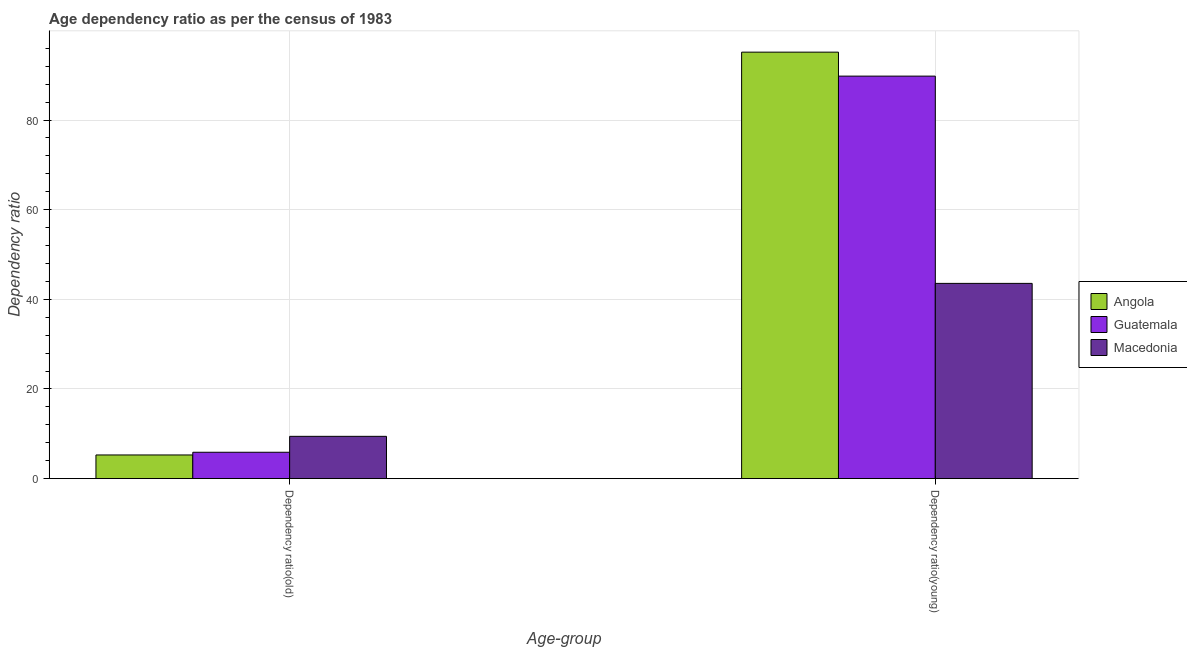Are the number of bars on each tick of the X-axis equal?
Offer a terse response. Yes. What is the label of the 1st group of bars from the left?
Your response must be concise. Dependency ratio(old). What is the age dependency ratio(old) in Guatemala?
Provide a succinct answer. 5.88. Across all countries, what is the maximum age dependency ratio(old)?
Your answer should be compact. 9.43. Across all countries, what is the minimum age dependency ratio(old)?
Your answer should be compact. 5.28. In which country was the age dependency ratio(old) maximum?
Make the answer very short. Macedonia. In which country was the age dependency ratio(old) minimum?
Keep it short and to the point. Angola. What is the total age dependency ratio(young) in the graph?
Your answer should be compact. 228.5. What is the difference between the age dependency ratio(old) in Macedonia and that in Angola?
Offer a very short reply. 4.15. What is the difference between the age dependency ratio(old) in Guatemala and the age dependency ratio(young) in Angola?
Ensure brevity in your answer.  -89.27. What is the average age dependency ratio(young) per country?
Your answer should be compact. 76.17. What is the difference between the age dependency ratio(young) and age dependency ratio(old) in Macedonia?
Make the answer very short. 34.13. In how many countries, is the age dependency ratio(young) greater than 48 ?
Give a very brief answer. 2. What is the ratio of the age dependency ratio(young) in Macedonia to that in Guatemala?
Offer a terse response. 0.49. Is the age dependency ratio(old) in Guatemala less than that in Angola?
Your answer should be very brief. No. What does the 2nd bar from the left in Dependency ratio(young) represents?
Your answer should be very brief. Guatemala. What does the 3rd bar from the right in Dependency ratio(old) represents?
Your response must be concise. Angola. How many countries are there in the graph?
Your answer should be compact. 3. Where does the legend appear in the graph?
Offer a very short reply. Center right. What is the title of the graph?
Ensure brevity in your answer.  Age dependency ratio as per the census of 1983. What is the label or title of the X-axis?
Offer a very short reply. Age-group. What is the label or title of the Y-axis?
Make the answer very short. Dependency ratio. What is the Dependency ratio of Angola in Dependency ratio(old)?
Offer a very short reply. 5.28. What is the Dependency ratio of Guatemala in Dependency ratio(old)?
Offer a terse response. 5.88. What is the Dependency ratio in Macedonia in Dependency ratio(old)?
Your response must be concise. 9.43. What is the Dependency ratio of Angola in Dependency ratio(young)?
Your answer should be very brief. 95.15. What is the Dependency ratio in Guatemala in Dependency ratio(young)?
Your answer should be compact. 89.8. What is the Dependency ratio in Macedonia in Dependency ratio(young)?
Provide a short and direct response. 43.56. Across all Age-group, what is the maximum Dependency ratio of Angola?
Give a very brief answer. 95.15. Across all Age-group, what is the maximum Dependency ratio of Guatemala?
Ensure brevity in your answer.  89.8. Across all Age-group, what is the maximum Dependency ratio in Macedonia?
Give a very brief answer. 43.56. Across all Age-group, what is the minimum Dependency ratio of Angola?
Your answer should be very brief. 5.28. Across all Age-group, what is the minimum Dependency ratio in Guatemala?
Provide a succinct answer. 5.88. Across all Age-group, what is the minimum Dependency ratio of Macedonia?
Ensure brevity in your answer.  9.43. What is the total Dependency ratio in Angola in the graph?
Provide a short and direct response. 100.42. What is the total Dependency ratio of Guatemala in the graph?
Your answer should be very brief. 95.68. What is the total Dependency ratio of Macedonia in the graph?
Your response must be concise. 52.99. What is the difference between the Dependency ratio in Angola in Dependency ratio(old) and that in Dependency ratio(young)?
Offer a terse response. -89.87. What is the difference between the Dependency ratio of Guatemala in Dependency ratio(old) and that in Dependency ratio(young)?
Your response must be concise. -83.92. What is the difference between the Dependency ratio in Macedonia in Dependency ratio(old) and that in Dependency ratio(young)?
Make the answer very short. -34.13. What is the difference between the Dependency ratio in Angola in Dependency ratio(old) and the Dependency ratio in Guatemala in Dependency ratio(young)?
Your response must be concise. -84.52. What is the difference between the Dependency ratio of Angola in Dependency ratio(old) and the Dependency ratio of Macedonia in Dependency ratio(young)?
Your answer should be very brief. -38.28. What is the difference between the Dependency ratio of Guatemala in Dependency ratio(old) and the Dependency ratio of Macedonia in Dependency ratio(young)?
Provide a succinct answer. -37.68. What is the average Dependency ratio of Angola per Age-group?
Make the answer very short. 50.21. What is the average Dependency ratio of Guatemala per Age-group?
Your answer should be very brief. 47.84. What is the average Dependency ratio of Macedonia per Age-group?
Ensure brevity in your answer.  26.49. What is the difference between the Dependency ratio in Angola and Dependency ratio in Guatemala in Dependency ratio(old)?
Keep it short and to the point. -0.6. What is the difference between the Dependency ratio in Angola and Dependency ratio in Macedonia in Dependency ratio(old)?
Keep it short and to the point. -4.15. What is the difference between the Dependency ratio in Guatemala and Dependency ratio in Macedonia in Dependency ratio(old)?
Offer a terse response. -3.55. What is the difference between the Dependency ratio of Angola and Dependency ratio of Guatemala in Dependency ratio(young)?
Your answer should be very brief. 5.35. What is the difference between the Dependency ratio in Angola and Dependency ratio in Macedonia in Dependency ratio(young)?
Give a very brief answer. 51.59. What is the difference between the Dependency ratio in Guatemala and Dependency ratio in Macedonia in Dependency ratio(young)?
Offer a terse response. 46.24. What is the ratio of the Dependency ratio in Angola in Dependency ratio(old) to that in Dependency ratio(young)?
Your answer should be compact. 0.06. What is the ratio of the Dependency ratio of Guatemala in Dependency ratio(old) to that in Dependency ratio(young)?
Provide a short and direct response. 0.07. What is the ratio of the Dependency ratio in Macedonia in Dependency ratio(old) to that in Dependency ratio(young)?
Your answer should be compact. 0.22. What is the difference between the highest and the second highest Dependency ratio of Angola?
Give a very brief answer. 89.87. What is the difference between the highest and the second highest Dependency ratio in Guatemala?
Ensure brevity in your answer.  83.92. What is the difference between the highest and the second highest Dependency ratio in Macedonia?
Give a very brief answer. 34.13. What is the difference between the highest and the lowest Dependency ratio of Angola?
Provide a short and direct response. 89.87. What is the difference between the highest and the lowest Dependency ratio of Guatemala?
Your response must be concise. 83.92. What is the difference between the highest and the lowest Dependency ratio of Macedonia?
Your response must be concise. 34.13. 